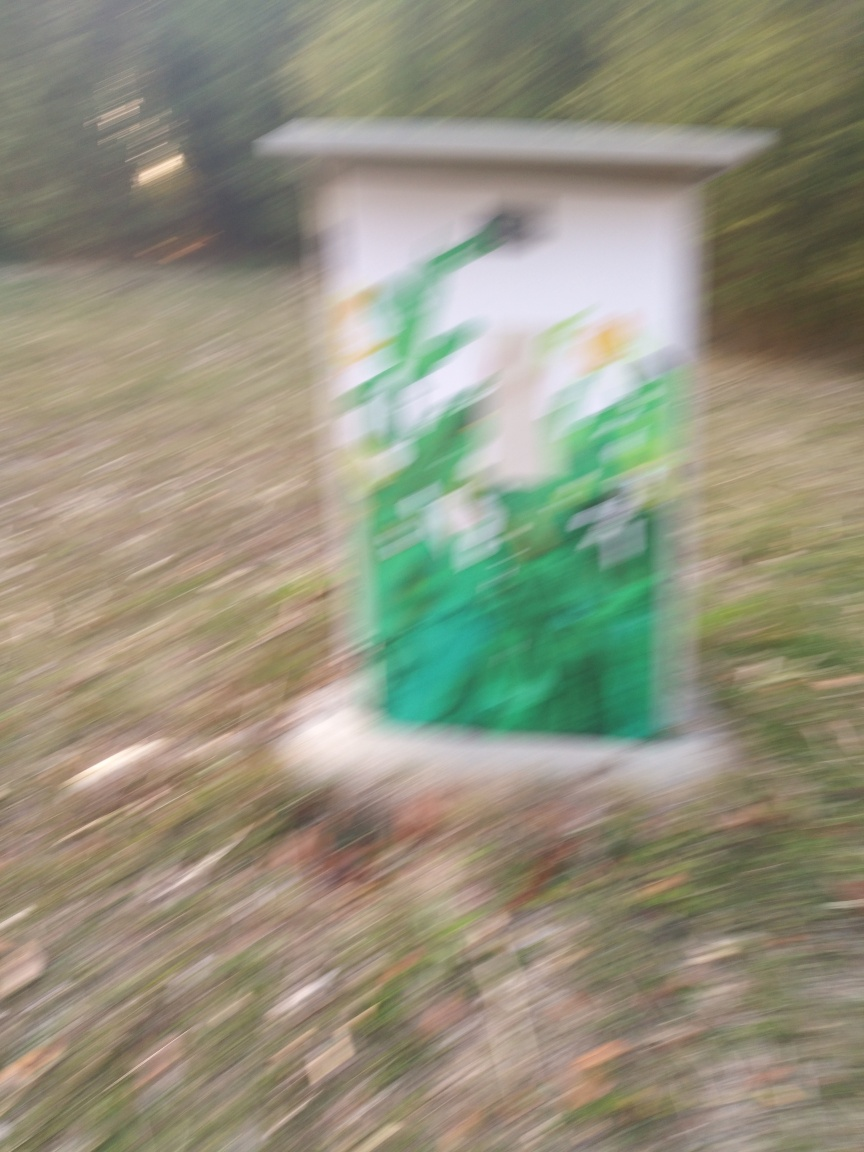What might be the reason for the blurriness of this image? There could be several reasons for the blurriness. The camera may have been moving during exposure, the focus could have been set incorrectly, or a slow shutter speed might have been used in a low-light situation without sufficient stabilization. 